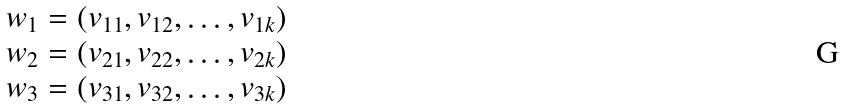<formula> <loc_0><loc_0><loc_500><loc_500>\begin{array} { l } w _ { 1 } = ( v _ { 1 1 } , v _ { 1 2 } , \dots , v _ { 1 k } ) \\ w _ { 2 } = ( v _ { 2 1 } , v _ { 2 2 } , \dots , v _ { 2 k } ) \\ w _ { 3 } = ( v _ { 3 1 } , v _ { 3 2 } , \dots , v _ { 3 k } ) \end{array}</formula> 